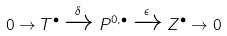Convert formula to latex. <formula><loc_0><loc_0><loc_500><loc_500>0 \to T ^ { \bullet } \xrightarrow { \delta } P ^ { 0 , \bullet } \xrightarrow { \epsilon } Z ^ { \bullet } \to 0</formula> 